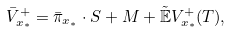Convert formula to latex. <formula><loc_0><loc_0><loc_500><loc_500>\bar { V } ^ { + } _ { x _ { * } } = \bar { \pi } _ { x _ { * } } \cdot S + M + \tilde { \mathbb { E } } V _ { x _ { * } } ^ { + } ( T ) ,</formula> 